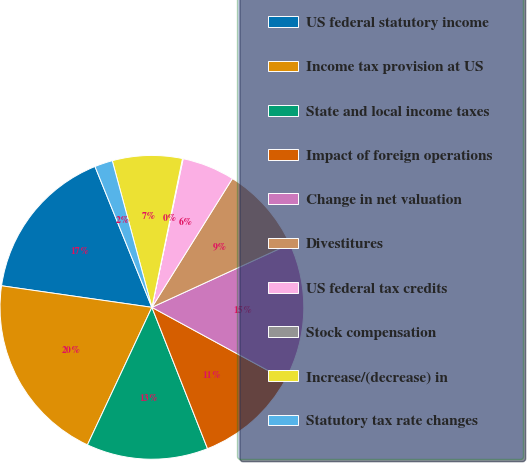<chart> <loc_0><loc_0><loc_500><loc_500><pie_chart><fcel>US federal statutory income<fcel>Income tax provision at US<fcel>State and local income taxes<fcel>Impact of foreign operations<fcel>Change in net valuation<fcel>Divestitures<fcel>US federal tax credits<fcel>Stock compensation<fcel>Increase/(decrease) in<fcel>Statutory tax rate changes<nl><fcel>16.62%<fcel>20.29%<fcel>12.94%<fcel>11.1%<fcel>14.78%<fcel>9.26%<fcel>5.59%<fcel>0.07%<fcel>7.43%<fcel>1.91%<nl></chart> 